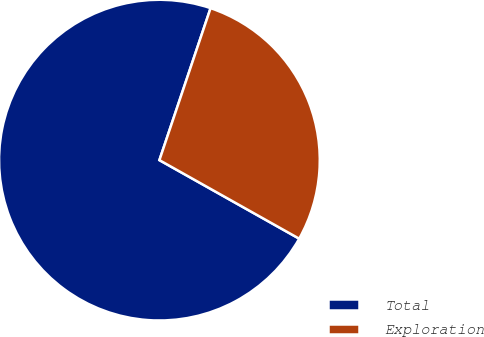<chart> <loc_0><loc_0><loc_500><loc_500><pie_chart><fcel>Total<fcel>Exploration<nl><fcel>72.02%<fcel>27.98%<nl></chart> 